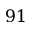<formula> <loc_0><loc_0><loc_500><loc_500>9 1</formula> 